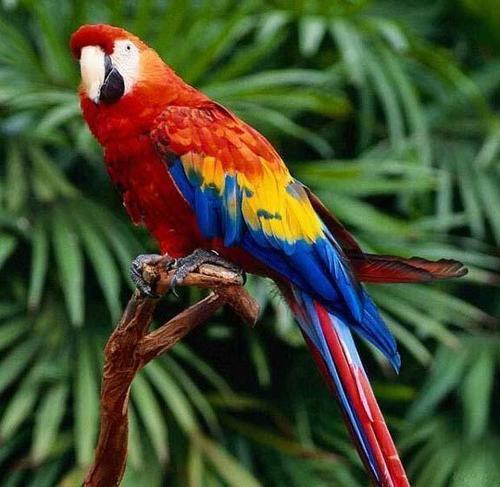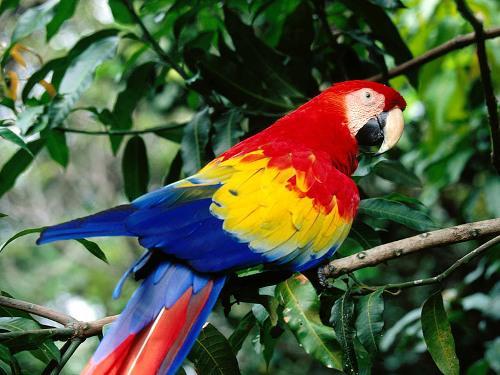The first image is the image on the left, the second image is the image on the right. For the images shown, is this caption "The right and left images contain the same number of parrots." true? Answer yes or no. Yes. The first image is the image on the left, the second image is the image on the right. For the images displayed, is the sentence "There are no less than four birds" factually correct? Answer yes or no. No. 